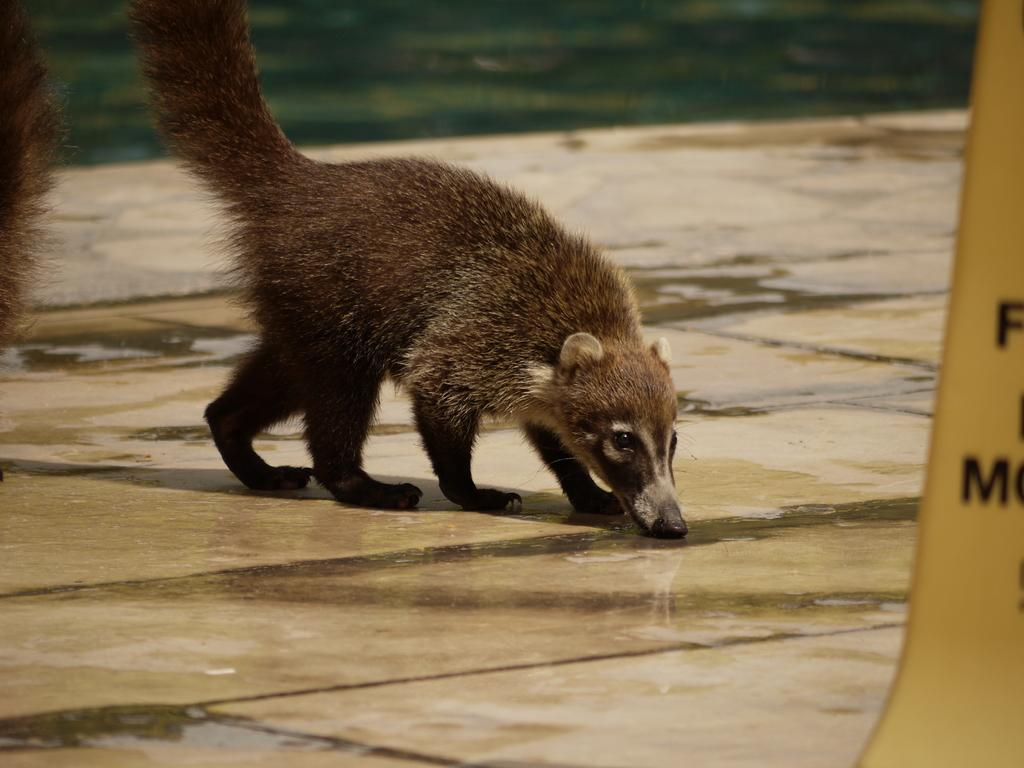What type of animal is in the image? There is an animal in the image, but its specific type is not mentioned in the facts. What color is the animal? The animal is brown in color. Where is the animal located in the image? The animal is on the floor. How many other animals are in the image? There are two other animals in the image, one on the left side and one on the right side. What is present on the floor along with the animals? There is water on the floor in the image. What type of straw is being used by the animals in the image? There is no straw present in the image; the animals are on the floor and there is water on the floor, but no straw is mentioned or visible. 